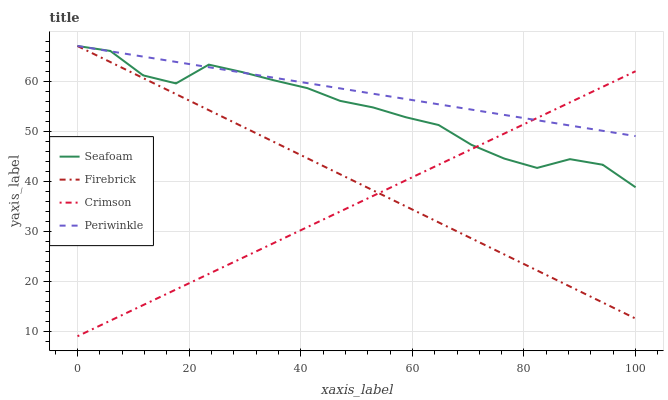Does Crimson have the minimum area under the curve?
Answer yes or no. Yes. Does Periwinkle have the maximum area under the curve?
Answer yes or no. Yes. Does Firebrick have the minimum area under the curve?
Answer yes or no. No. Does Firebrick have the maximum area under the curve?
Answer yes or no. No. Is Firebrick the smoothest?
Answer yes or no. Yes. Is Seafoam the roughest?
Answer yes or no. Yes. Is Periwinkle the smoothest?
Answer yes or no. No. Is Periwinkle the roughest?
Answer yes or no. No. Does Crimson have the lowest value?
Answer yes or no. Yes. Does Firebrick have the lowest value?
Answer yes or no. No. Does Seafoam have the highest value?
Answer yes or no. Yes. Does Seafoam intersect Firebrick?
Answer yes or no. Yes. Is Seafoam less than Firebrick?
Answer yes or no. No. Is Seafoam greater than Firebrick?
Answer yes or no. No. 